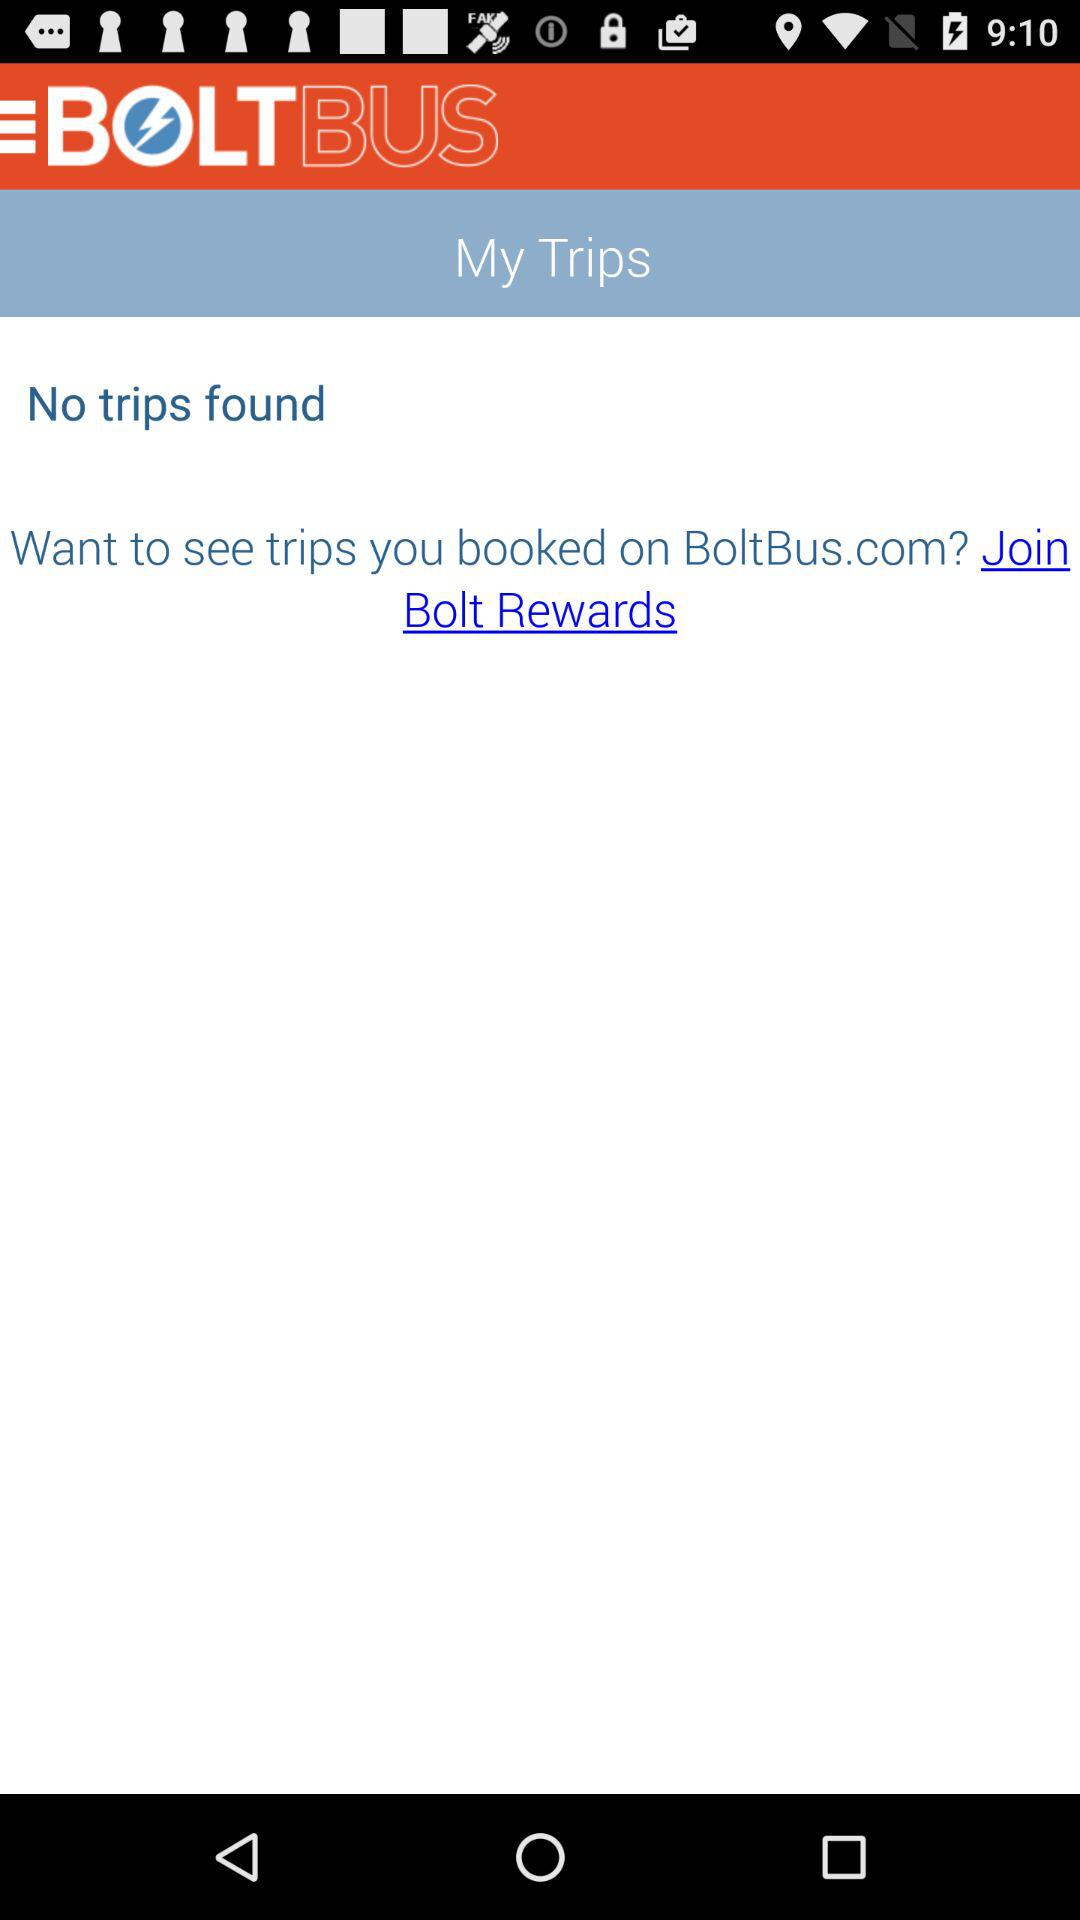Which city does this application serve?
When the provided information is insufficient, respond with <no answer>. <no answer> 